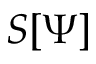<formula> <loc_0><loc_0><loc_500><loc_500>S [ \Psi ]</formula> 